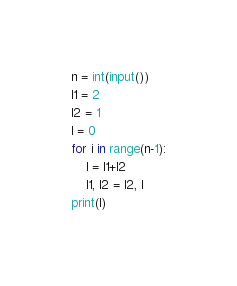<code> <loc_0><loc_0><loc_500><loc_500><_Python_>n = int(input())
l1 = 2
l2 = 1
l = 0
for i in range(n-1):
    l = l1+l2
    l1, l2 = l2, l
print(l)</code> 